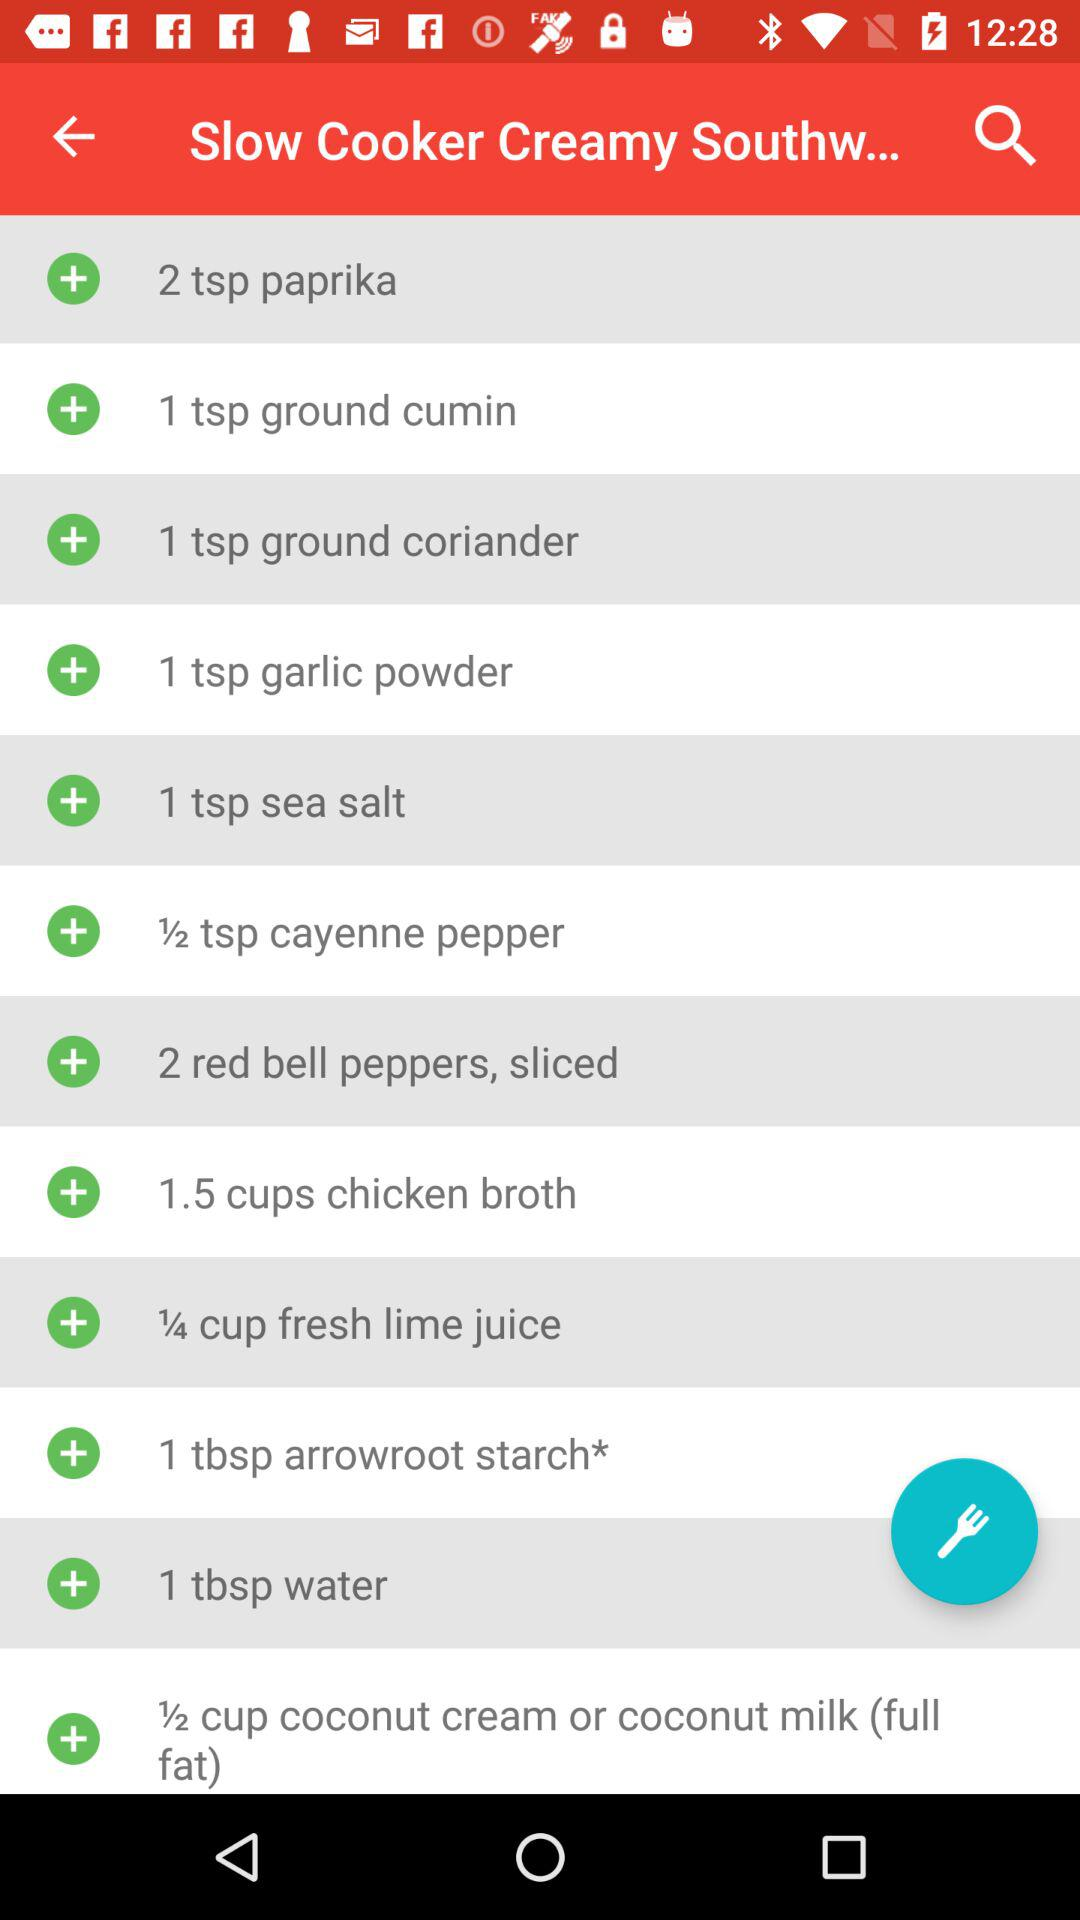How much sea salt is required? The quantity of sea salt required is 1 teaspoon. 